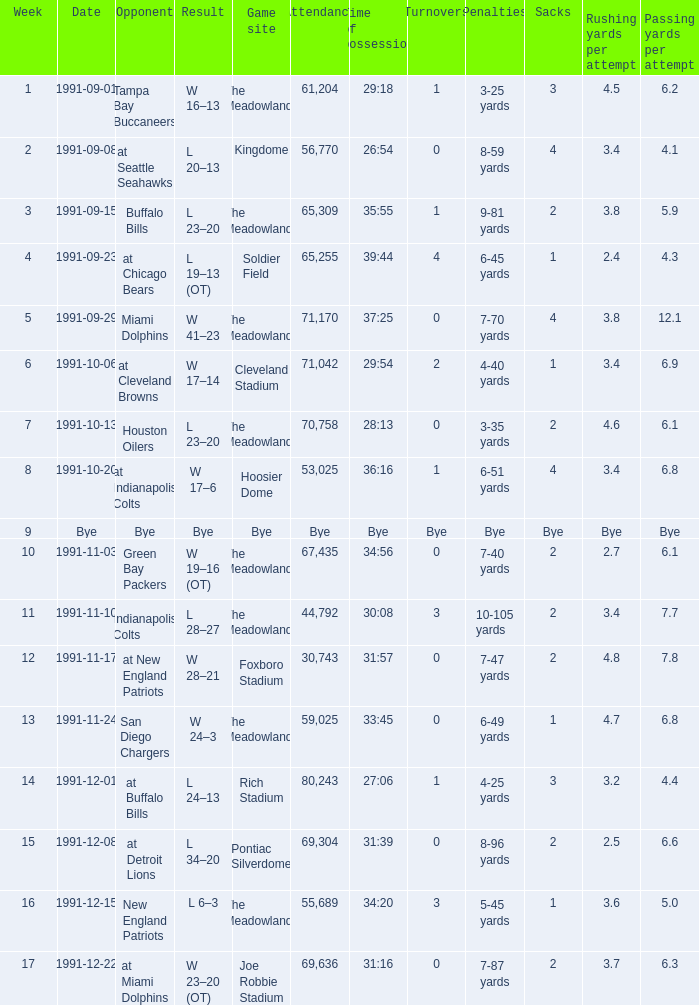Which Opponent was played on 1991-10-13? Houston Oilers. 